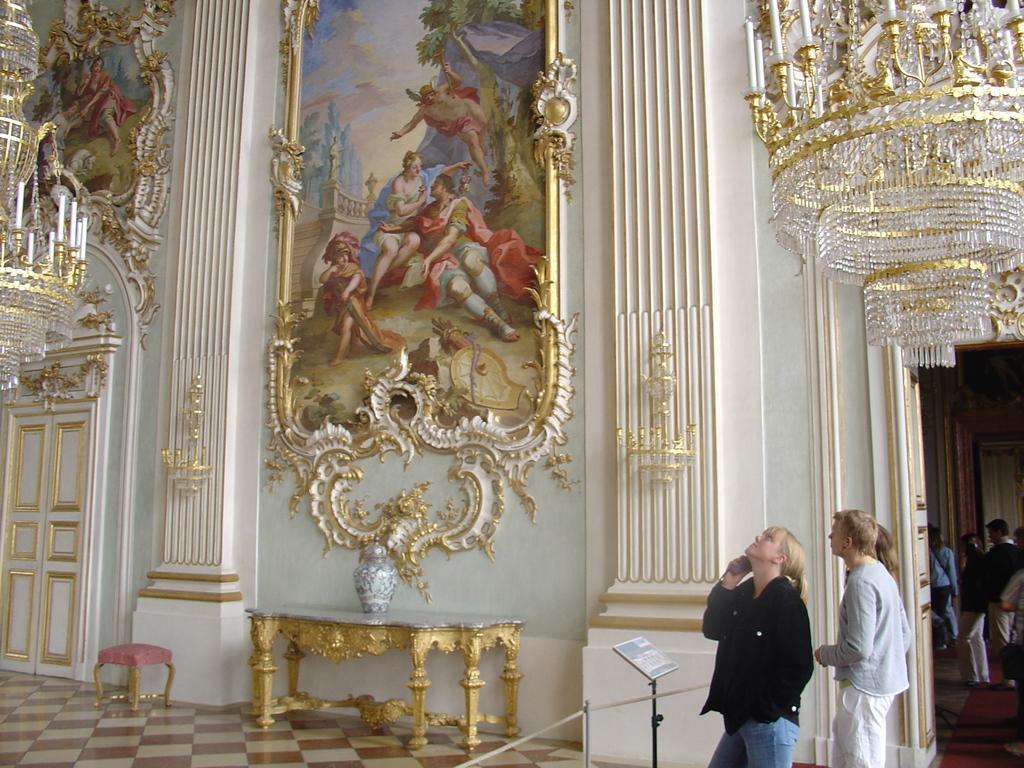Please provide a concise description of this image. In this image, I can see the paintings and designs on the wall. On the left side of the image, I can see a door. There is a stool and a object on the table, which are placed on the floor. On the left and right side of the image, I can see the chandeliers hanging. At the bottom of the image, I can see few people standing and a board with a stand. 